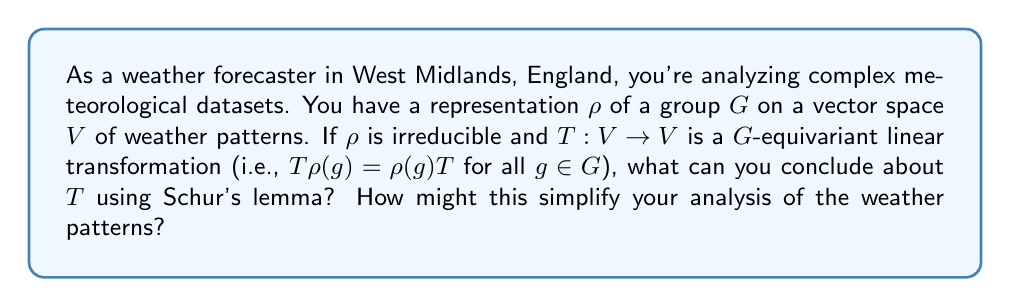Provide a solution to this math problem. Let's approach this step-by-step:

1) First, recall Schur's lemma: If $\rho$ is an irreducible representation of a group $G$ on a complex vector space $V$, and $T: V \rightarrow V$ is a $G$-equivariant linear transformation, then $T$ is a scalar multiple of the identity.

2) In our case, we're given that $\rho$ is irreducible and $T$ is $G$-equivariant. Therefore, Schur's lemma applies directly.

3) This means that $T = \lambda I$ for some scalar $\lambda$, where $I$ is the identity transformation.

4) In the context of weather patterns, this has a significant implication. It means that the $G$-equivariant transformation $T$ acts uniformly on all weather patterns in $V$.

5) Practically, this could mean that certain symmetries or group actions in the weather system lead to uniform changes across all weather patterns.

6) This simplifies the analysis because instead of having to consider how $T$ affects each weather pattern individually, we know it scales all patterns by the same factor $\lambda$.

7) For forecasting, this could allow you to predict changes in weather patterns more efficiently, as you only need to determine the scalar $\lambda$ rather than a full transformation matrix.
Answer: $T = \lambda I$ for some scalar $\lambda$ 